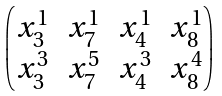Convert formula to latex. <formula><loc_0><loc_0><loc_500><loc_500>\begin{pmatrix} x _ { 3 } ^ { 1 } & x _ { 7 } ^ { 1 } & x _ { 4 } ^ { 1 } & x _ { 8 } ^ { 1 } \\ x _ { 3 } ^ { 3 } & x _ { 7 } ^ { 5 } & x _ { 4 } ^ { 3 } & x _ { 8 } ^ { 4 } \end{pmatrix}</formula> 